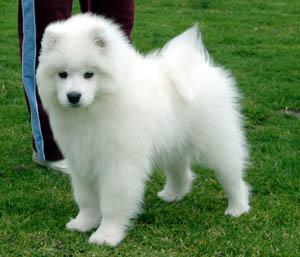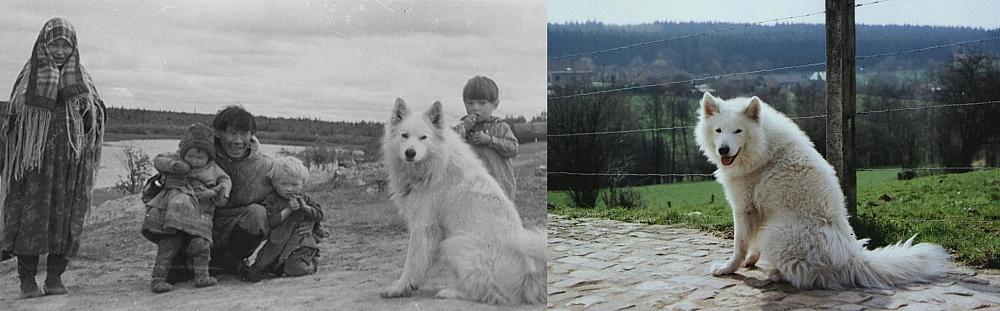The first image is the image on the left, the second image is the image on the right. Examine the images to the left and right. Is the description "In at least one image there are no less than four dogs with a white chest fur standing in a line next to each other on grass." accurate? Answer yes or no. No. The first image is the image on the left, the second image is the image on the right. For the images displayed, is the sentence "In one of the images, there are two white dogs and at least one dog of another color." factually correct? Answer yes or no. No. 